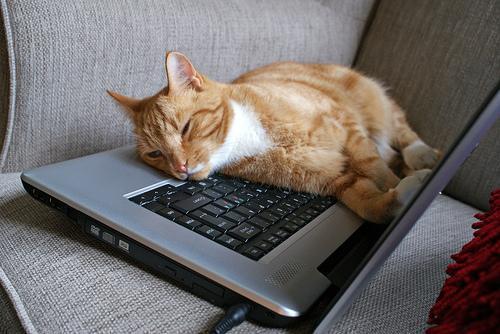How many cats?
Give a very brief answer. 1. 